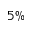Convert formula to latex. <formula><loc_0><loc_0><loc_500><loc_500>5 \%</formula> 